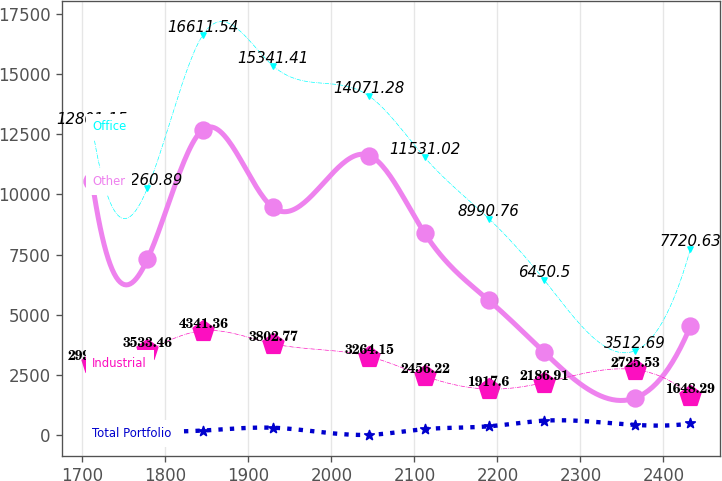<chart> <loc_0><loc_0><loc_500><loc_500><line_chart><ecel><fcel>Office<fcel>Other<fcel>Industrial<fcel>Total Portfolio<nl><fcel>1711.83<fcel>12801.1<fcel>10534<fcel>2994.84<fcel>79.15<nl><fcel>1778.46<fcel>10260.9<fcel>7308.64<fcel>3533.46<fcel>137.91<nl><fcel>1845.09<fcel>16611.5<fcel>12684.2<fcel>4341.36<fcel>196.67<nl><fcel>1929.36<fcel>15341.4<fcel>9458.88<fcel>3802.77<fcel>314.19<nl><fcel>2045.8<fcel>14071.3<fcel>11609.1<fcel>3264.15<fcel>20.39<nl><fcel>2112.43<fcel>11531<fcel>8383.76<fcel>2456.22<fcel>255.43<nl><fcel>2189.7<fcel>8990.76<fcel>5598.82<fcel>1917.6<fcel>372.95<nl><fcel>2256.33<fcel>6450.5<fcel>3448.58<fcel>2186.91<fcel>608.02<nl><fcel>2365.84<fcel>3512.69<fcel>1547.67<fcel>2725.53<fcel>431.71<nl><fcel>2432.47<fcel>7720.63<fcel>4523.7<fcel>1648.29<fcel>490.47<nl></chart> 